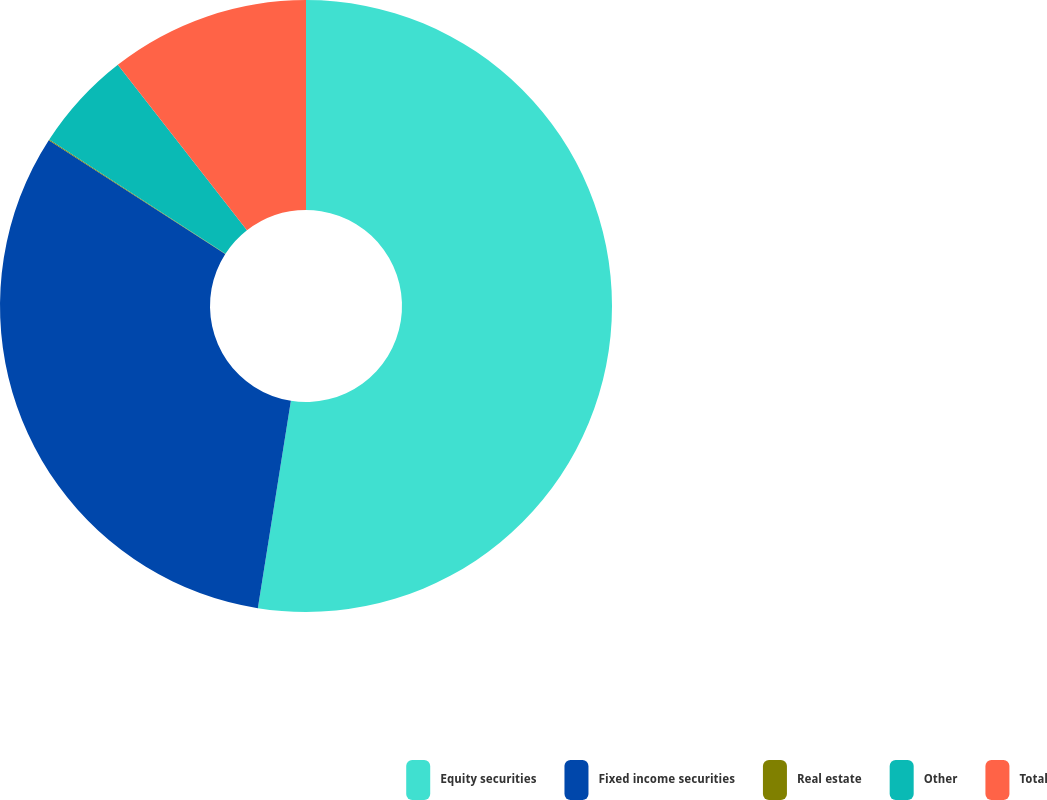Convert chart to OTSL. <chart><loc_0><loc_0><loc_500><loc_500><pie_chart><fcel>Equity securities<fcel>Fixed income securities<fcel>Real estate<fcel>Other<fcel>Total<nl><fcel>52.51%<fcel>31.59%<fcel>0.05%<fcel>5.3%<fcel>10.54%<nl></chart> 